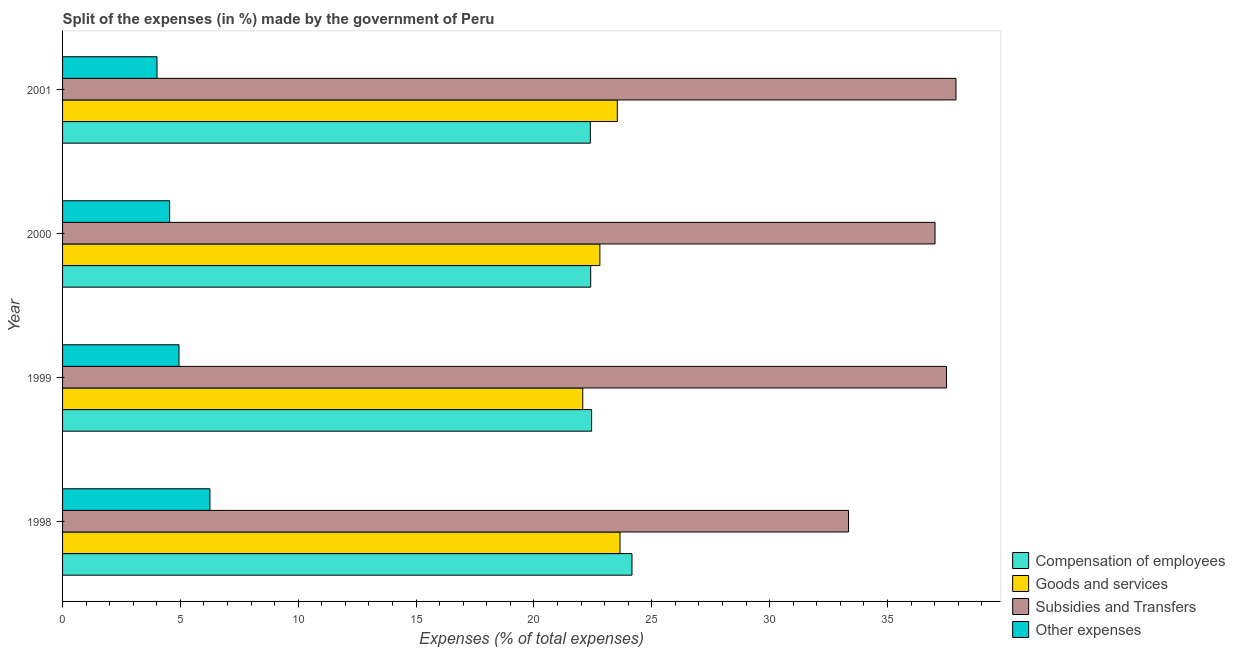How many groups of bars are there?
Your answer should be very brief. 4. Are the number of bars per tick equal to the number of legend labels?
Your response must be concise. Yes. How many bars are there on the 2nd tick from the top?
Keep it short and to the point. 4. What is the label of the 1st group of bars from the top?
Your response must be concise. 2001. What is the percentage of amount spent on goods and services in 2000?
Give a very brief answer. 22.8. Across all years, what is the maximum percentage of amount spent on goods and services?
Ensure brevity in your answer.  23.65. Across all years, what is the minimum percentage of amount spent on compensation of employees?
Offer a very short reply. 22.39. In which year was the percentage of amount spent on goods and services maximum?
Ensure brevity in your answer.  1998. In which year was the percentage of amount spent on other expenses minimum?
Provide a succinct answer. 2001. What is the total percentage of amount spent on goods and services in the graph?
Offer a very short reply. 92.05. What is the difference between the percentage of amount spent on subsidies in 2000 and that in 2001?
Offer a very short reply. -0.89. What is the difference between the percentage of amount spent on goods and services in 2001 and the percentage of amount spent on compensation of employees in 1999?
Keep it short and to the point. 1.09. What is the average percentage of amount spent on compensation of employees per year?
Provide a short and direct response. 22.85. In the year 1998, what is the difference between the percentage of amount spent on goods and services and percentage of amount spent on other expenses?
Make the answer very short. 17.4. What is the ratio of the percentage of amount spent on subsidies in 1999 to that in 2001?
Your response must be concise. 0.99. What is the difference between the highest and the second highest percentage of amount spent on goods and services?
Your answer should be very brief. 0.11. What is the difference between the highest and the lowest percentage of amount spent on compensation of employees?
Ensure brevity in your answer.  1.77. In how many years, is the percentage of amount spent on compensation of employees greater than the average percentage of amount spent on compensation of employees taken over all years?
Provide a short and direct response. 1. Is it the case that in every year, the sum of the percentage of amount spent on compensation of employees and percentage of amount spent on other expenses is greater than the sum of percentage of amount spent on subsidies and percentage of amount spent on goods and services?
Provide a succinct answer. Yes. What does the 3rd bar from the top in 1998 represents?
Your response must be concise. Goods and services. What does the 4th bar from the bottom in 1999 represents?
Provide a succinct answer. Other expenses. Are all the bars in the graph horizontal?
Your response must be concise. Yes. What is the difference between two consecutive major ticks on the X-axis?
Make the answer very short. 5. Does the graph contain grids?
Offer a terse response. No. How many legend labels are there?
Your response must be concise. 4. What is the title of the graph?
Make the answer very short. Split of the expenses (in %) made by the government of Peru. What is the label or title of the X-axis?
Keep it short and to the point. Expenses (% of total expenses). What is the Expenses (% of total expenses) of Compensation of employees in 1998?
Your answer should be compact. 24.16. What is the Expenses (% of total expenses) of Goods and services in 1998?
Offer a terse response. 23.65. What is the Expenses (% of total expenses) in Subsidies and Transfers in 1998?
Offer a very short reply. 33.35. What is the Expenses (% of total expenses) of Other expenses in 1998?
Give a very brief answer. 6.25. What is the Expenses (% of total expenses) of Compensation of employees in 1999?
Your response must be concise. 22.45. What is the Expenses (% of total expenses) in Goods and services in 1999?
Offer a terse response. 22.07. What is the Expenses (% of total expenses) in Subsidies and Transfers in 1999?
Provide a succinct answer. 37.5. What is the Expenses (% of total expenses) of Other expenses in 1999?
Your answer should be compact. 4.94. What is the Expenses (% of total expenses) of Compensation of employees in 2000?
Keep it short and to the point. 22.41. What is the Expenses (% of total expenses) in Goods and services in 2000?
Give a very brief answer. 22.8. What is the Expenses (% of total expenses) of Subsidies and Transfers in 2000?
Your answer should be very brief. 37.01. What is the Expenses (% of total expenses) of Other expenses in 2000?
Ensure brevity in your answer.  4.54. What is the Expenses (% of total expenses) of Compensation of employees in 2001?
Your response must be concise. 22.39. What is the Expenses (% of total expenses) of Goods and services in 2001?
Your response must be concise. 23.54. What is the Expenses (% of total expenses) in Subsidies and Transfers in 2001?
Ensure brevity in your answer.  37.9. What is the Expenses (% of total expenses) in Other expenses in 2001?
Ensure brevity in your answer.  4.01. Across all years, what is the maximum Expenses (% of total expenses) of Compensation of employees?
Your answer should be compact. 24.16. Across all years, what is the maximum Expenses (% of total expenses) of Goods and services?
Provide a succinct answer. 23.65. Across all years, what is the maximum Expenses (% of total expenses) in Subsidies and Transfers?
Ensure brevity in your answer.  37.9. Across all years, what is the maximum Expenses (% of total expenses) of Other expenses?
Offer a very short reply. 6.25. Across all years, what is the minimum Expenses (% of total expenses) of Compensation of employees?
Make the answer very short. 22.39. Across all years, what is the minimum Expenses (% of total expenses) of Goods and services?
Give a very brief answer. 22.07. Across all years, what is the minimum Expenses (% of total expenses) of Subsidies and Transfers?
Your response must be concise. 33.35. Across all years, what is the minimum Expenses (% of total expenses) in Other expenses?
Give a very brief answer. 4.01. What is the total Expenses (% of total expenses) of Compensation of employees in the graph?
Offer a very short reply. 91.4. What is the total Expenses (% of total expenses) of Goods and services in the graph?
Keep it short and to the point. 92.05. What is the total Expenses (% of total expenses) of Subsidies and Transfers in the graph?
Make the answer very short. 145.77. What is the total Expenses (% of total expenses) in Other expenses in the graph?
Provide a succinct answer. 19.74. What is the difference between the Expenses (% of total expenses) in Compensation of employees in 1998 and that in 1999?
Your response must be concise. 1.71. What is the difference between the Expenses (% of total expenses) of Goods and services in 1998 and that in 1999?
Offer a terse response. 1.58. What is the difference between the Expenses (% of total expenses) in Subsidies and Transfers in 1998 and that in 1999?
Your answer should be very brief. -4.16. What is the difference between the Expenses (% of total expenses) of Other expenses in 1998 and that in 1999?
Offer a very short reply. 1.31. What is the difference between the Expenses (% of total expenses) of Compensation of employees in 1998 and that in 2000?
Make the answer very short. 1.75. What is the difference between the Expenses (% of total expenses) in Goods and services in 1998 and that in 2000?
Give a very brief answer. 0.85. What is the difference between the Expenses (% of total expenses) in Subsidies and Transfers in 1998 and that in 2000?
Your response must be concise. -3.67. What is the difference between the Expenses (% of total expenses) in Other expenses in 1998 and that in 2000?
Provide a short and direct response. 1.71. What is the difference between the Expenses (% of total expenses) in Compensation of employees in 1998 and that in 2001?
Provide a succinct answer. 1.77. What is the difference between the Expenses (% of total expenses) in Goods and services in 1998 and that in 2001?
Keep it short and to the point. 0.11. What is the difference between the Expenses (% of total expenses) of Subsidies and Transfers in 1998 and that in 2001?
Provide a short and direct response. -4.56. What is the difference between the Expenses (% of total expenses) of Other expenses in 1998 and that in 2001?
Ensure brevity in your answer.  2.25. What is the difference between the Expenses (% of total expenses) of Compensation of employees in 1999 and that in 2000?
Ensure brevity in your answer.  0.04. What is the difference between the Expenses (% of total expenses) of Goods and services in 1999 and that in 2000?
Keep it short and to the point. -0.73. What is the difference between the Expenses (% of total expenses) in Subsidies and Transfers in 1999 and that in 2000?
Offer a very short reply. 0.49. What is the difference between the Expenses (% of total expenses) in Other expenses in 1999 and that in 2000?
Give a very brief answer. 0.4. What is the difference between the Expenses (% of total expenses) in Compensation of employees in 1999 and that in 2001?
Offer a terse response. 0.05. What is the difference between the Expenses (% of total expenses) of Goods and services in 1999 and that in 2001?
Your answer should be compact. -1.47. What is the difference between the Expenses (% of total expenses) in Subsidies and Transfers in 1999 and that in 2001?
Offer a very short reply. -0.4. What is the difference between the Expenses (% of total expenses) in Other expenses in 1999 and that in 2001?
Keep it short and to the point. 0.93. What is the difference between the Expenses (% of total expenses) in Compensation of employees in 2000 and that in 2001?
Give a very brief answer. 0.02. What is the difference between the Expenses (% of total expenses) of Goods and services in 2000 and that in 2001?
Keep it short and to the point. -0.74. What is the difference between the Expenses (% of total expenses) in Subsidies and Transfers in 2000 and that in 2001?
Your answer should be compact. -0.89. What is the difference between the Expenses (% of total expenses) of Other expenses in 2000 and that in 2001?
Your answer should be very brief. 0.54. What is the difference between the Expenses (% of total expenses) of Compensation of employees in 1998 and the Expenses (% of total expenses) of Goods and services in 1999?
Make the answer very short. 2.09. What is the difference between the Expenses (% of total expenses) in Compensation of employees in 1998 and the Expenses (% of total expenses) in Subsidies and Transfers in 1999?
Your response must be concise. -13.34. What is the difference between the Expenses (% of total expenses) of Compensation of employees in 1998 and the Expenses (% of total expenses) of Other expenses in 1999?
Provide a succinct answer. 19.22. What is the difference between the Expenses (% of total expenses) of Goods and services in 1998 and the Expenses (% of total expenses) of Subsidies and Transfers in 1999?
Offer a very short reply. -13.85. What is the difference between the Expenses (% of total expenses) in Goods and services in 1998 and the Expenses (% of total expenses) in Other expenses in 1999?
Provide a succinct answer. 18.71. What is the difference between the Expenses (% of total expenses) in Subsidies and Transfers in 1998 and the Expenses (% of total expenses) in Other expenses in 1999?
Provide a short and direct response. 28.41. What is the difference between the Expenses (% of total expenses) in Compensation of employees in 1998 and the Expenses (% of total expenses) in Goods and services in 2000?
Provide a short and direct response. 1.36. What is the difference between the Expenses (% of total expenses) in Compensation of employees in 1998 and the Expenses (% of total expenses) in Subsidies and Transfers in 2000?
Ensure brevity in your answer.  -12.86. What is the difference between the Expenses (% of total expenses) of Compensation of employees in 1998 and the Expenses (% of total expenses) of Other expenses in 2000?
Offer a terse response. 19.62. What is the difference between the Expenses (% of total expenses) of Goods and services in 1998 and the Expenses (% of total expenses) of Subsidies and Transfers in 2000?
Ensure brevity in your answer.  -13.36. What is the difference between the Expenses (% of total expenses) in Goods and services in 1998 and the Expenses (% of total expenses) in Other expenses in 2000?
Your response must be concise. 19.11. What is the difference between the Expenses (% of total expenses) in Subsidies and Transfers in 1998 and the Expenses (% of total expenses) in Other expenses in 2000?
Ensure brevity in your answer.  28.8. What is the difference between the Expenses (% of total expenses) in Compensation of employees in 1998 and the Expenses (% of total expenses) in Goods and services in 2001?
Provide a succinct answer. 0.62. What is the difference between the Expenses (% of total expenses) of Compensation of employees in 1998 and the Expenses (% of total expenses) of Subsidies and Transfers in 2001?
Your response must be concise. -13.75. What is the difference between the Expenses (% of total expenses) of Compensation of employees in 1998 and the Expenses (% of total expenses) of Other expenses in 2001?
Offer a terse response. 20.15. What is the difference between the Expenses (% of total expenses) in Goods and services in 1998 and the Expenses (% of total expenses) in Subsidies and Transfers in 2001?
Provide a succinct answer. -14.25. What is the difference between the Expenses (% of total expenses) of Goods and services in 1998 and the Expenses (% of total expenses) of Other expenses in 2001?
Provide a short and direct response. 19.64. What is the difference between the Expenses (% of total expenses) in Subsidies and Transfers in 1998 and the Expenses (% of total expenses) in Other expenses in 2001?
Keep it short and to the point. 29.34. What is the difference between the Expenses (% of total expenses) of Compensation of employees in 1999 and the Expenses (% of total expenses) of Goods and services in 2000?
Provide a succinct answer. -0.35. What is the difference between the Expenses (% of total expenses) of Compensation of employees in 1999 and the Expenses (% of total expenses) of Subsidies and Transfers in 2000?
Make the answer very short. -14.57. What is the difference between the Expenses (% of total expenses) of Compensation of employees in 1999 and the Expenses (% of total expenses) of Other expenses in 2000?
Your answer should be compact. 17.9. What is the difference between the Expenses (% of total expenses) in Goods and services in 1999 and the Expenses (% of total expenses) in Subsidies and Transfers in 2000?
Offer a terse response. -14.94. What is the difference between the Expenses (% of total expenses) of Goods and services in 1999 and the Expenses (% of total expenses) of Other expenses in 2000?
Ensure brevity in your answer.  17.53. What is the difference between the Expenses (% of total expenses) of Subsidies and Transfers in 1999 and the Expenses (% of total expenses) of Other expenses in 2000?
Your answer should be compact. 32.96. What is the difference between the Expenses (% of total expenses) in Compensation of employees in 1999 and the Expenses (% of total expenses) in Goods and services in 2001?
Offer a terse response. -1.09. What is the difference between the Expenses (% of total expenses) in Compensation of employees in 1999 and the Expenses (% of total expenses) in Subsidies and Transfers in 2001?
Provide a succinct answer. -15.46. What is the difference between the Expenses (% of total expenses) in Compensation of employees in 1999 and the Expenses (% of total expenses) in Other expenses in 2001?
Give a very brief answer. 18.44. What is the difference between the Expenses (% of total expenses) of Goods and services in 1999 and the Expenses (% of total expenses) of Subsidies and Transfers in 2001?
Keep it short and to the point. -15.83. What is the difference between the Expenses (% of total expenses) of Goods and services in 1999 and the Expenses (% of total expenses) of Other expenses in 2001?
Give a very brief answer. 18.06. What is the difference between the Expenses (% of total expenses) in Subsidies and Transfers in 1999 and the Expenses (% of total expenses) in Other expenses in 2001?
Your answer should be very brief. 33.49. What is the difference between the Expenses (% of total expenses) of Compensation of employees in 2000 and the Expenses (% of total expenses) of Goods and services in 2001?
Provide a succinct answer. -1.13. What is the difference between the Expenses (% of total expenses) of Compensation of employees in 2000 and the Expenses (% of total expenses) of Subsidies and Transfers in 2001?
Your response must be concise. -15.5. What is the difference between the Expenses (% of total expenses) in Compensation of employees in 2000 and the Expenses (% of total expenses) in Other expenses in 2001?
Provide a succinct answer. 18.4. What is the difference between the Expenses (% of total expenses) in Goods and services in 2000 and the Expenses (% of total expenses) in Subsidies and Transfers in 2001?
Offer a very short reply. -15.11. What is the difference between the Expenses (% of total expenses) in Goods and services in 2000 and the Expenses (% of total expenses) in Other expenses in 2001?
Make the answer very short. 18.79. What is the difference between the Expenses (% of total expenses) of Subsidies and Transfers in 2000 and the Expenses (% of total expenses) of Other expenses in 2001?
Provide a succinct answer. 33.01. What is the average Expenses (% of total expenses) of Compensation of employees per year?
Your response must be concise. 22.85. What is the average Expenses (% of total expenses) of Goods and services per year?
Make the answer very short. 23.01. What is the average Expenses (% of total expenses) in Subsidies and Transfers per year?
Your answer should be very brief. 36.44. What is the average Expenses (% of total expenses) in Other expenses per year?
Offer a very short reply. 4.94. In the year 1998, what is the difference between the Expenses (% of total expenses) in Compensation of employees and Expenses (% of total expenses) in Goods and services?
Offer a very short reply. 0.51. In the year 1998, what is the difference between the Expenses (% of total expenses) of Compensation of employees and Expenses (% of total expenses) of Subsidies and Transfers?
Ensure brevity in your answer.  -9.19. In the year 1998, what is the difference between the Expenses (% of total expenses) in Compensation of employees and Expenses (% of total expenses) in Other expenses?
Keep it short and to the point. 17.91. In the year 1998, what is the difference between the Expenses (% of total expenses) in Goods and services and Expenses (% of total expenses) in Subsidies and Transfers?
Offer a terse response. -9.7. In the year 1998, what is the difference between the Expenses (% of total expenses) in Goods and services and Expenses (% of total expenses) in Other expenses?
Provide a succinct answer. 17.4. In the year 1998, what is the difference between the Expenses (% of total expenses) in Subsidies and Transfers and Expenses (% of total expenses) in Other expenses?
Your answer should be compact. 27.09. In the year 1999, what is the difference between the Expenses (% of total expenses) in Compensation of employees and Expenses (% of total expenses) in Subsidies and Transfers?
Keep it short and to the point. -15.06. In the year 1999, what is the difference between the Expenses (% of total expenses) of Compensation of employees and Expenses (% of total expenses) of Other expenses?
Your answer should be compact. 17.51. In the year 1999, what is the difference between the Expenses (% of total expenses) of Goods and services and Expenses (% of total expenses) of Subsidies and Transfers?
Make the answer very short. -15.43. In the year 1999, what is the difference between the Expenses (% of total expenses) in Goods and services and Expenses (% of total expenses) in Other expenses?
Provide a short and direct response. 17.13. In the year 1999, what is the difference between the Expenses (% of total expenses) in Subsidies and Transfers and Expenses (% of total expenses) in Other expenses?
Give a very brief answer. 32.56. In the year 2000, what is the difference between the Expenses (% of total expenses) of Compensation of employees and Expenses (% of total expenses) of Goods and services?
Provide a short and direct response. -0.39. In the year 2000, what is the difference between the Expenses (% of total expenses) of Compensation of employees and Expenses (% of total expenses) of Subsidies and Transfers?
Keep it short and to the point. -14.61. In the year 2000, what is the difference between the Expenses (% of total expenses) of Compensation of employees and Expenses (% of total expenses) of Other expenses?
Keep it short and to the point. 17.86. In the year 2000, what is the difference between the Expenses (% of total expenses) of Goods and services and Expenses (% of total expenses) of Subsidies and Transfers?
Your response must be concise. -14.22. In the year 2000, what is the difference between the Expenses (% of total expenses) in Goods and services and Expenses (% of total expenses) in Other expenses?
Your answer should be compact. 18.25. In the year 2000, what is the difference between the Expenses (% of total expenses) in Subsidies and Transfers and Expenses (% of total expenses) in Other expenses?
Your response must be concise. 32.47. In the year 2001, what is the difference between the Expenses (% of total expenses) of Compensation of employees and Expenses (% of total expenses) of Goods and services?
Provide a succinct answer. -1.15. In the year 2001, what is the difference between the Expenses (% of total expenses) in Compensation of employees and Expenses (% of total expenses) in Subsidies and Transfers?
Ensure brevity in your answer.  -15.51. In the year 2001, what is the difference between the Expenses (% of total expenses) of Compensation of employees and Expenses (% of total expenses) of Other expenses?
Provide a succinct answer. 18.38. In the year 2001, what is the difference between the Expenses (% of total expenses) of Goods and services and Expenses (% of total expenses) of Subsidies and Transfers?
Your answer should be compact. -14.37. In the year 2001, what is the difference between the Expenses (% of total expenses) in Goods and services and Expenses (% of total expenses) in Other expenses?
Offer a terse response. 19.53. In the year 2001, what is the difference between the Expenses (% of total expenses) of Subsidies and Transfers and Expenses (% of total expenses) of Other expenses?
Ensure brevity in your answer.  33.9. What is the ratio of the Expenses (% of total expenses) in Compensation of employees in 1998 to that in 1999?
Offer a terse response. 1.08. What is the ratio of the Expenses (% of total expenses) in Goods and services in 1998 to that in 1999?
Keep it short and to the point. 1.07. What is the ratio of the Expenses (% of total expenses) in Subsidies and Transfers in 1998 to that in 1999?
Your answer should be very brief. 0.89. What is the ratio of the Expenses (% of total expenses) of Other expenses in 1998 to that in 1999?
Offer a terse response. 1.27. What is the ratio of the Expenses (% of total expenses) in Compensation of employees in 1998 to that in 2000?
Offer a very short reply. 1.08. What is the ratio of the Expenses (% of total expenses) in Goods and services in 1998 to that in 2000?
Keep it short and to the point. 1.04. What is the ratio of the Expenses (% of total expenses) of Subsidies and Transfers in 1998 to that in 2000?
Keep it short and to the point. 0.9. What is the ratio of the Expenses (% of total expenses) in Other expenses in 1998 to that in 2000?
Your answer should be compact. 1.38. What is the ratio of the Expenses (% of total expenses) of Compensation of employees in 1998 to that in 2001?
Provide a short and direct response. 1.08. What is the ratio of the Expenses (% of total expenses) in Goods and services in 1998 to that in 2001?
Offer a terse response. 1. What is the ratio of the Expenses (% of total expenses) in Subsidies and Transfers in 1998 to that in 2001?
Your response must be concise. 0.88. What is the ratio of the Expenses (% of total expenses) of Other expenses in 1998 to that in 2001?
Your response must be concise. 1.56. What is the ratio of the Expenses (% of total expenses) in Goods and services in 1999 to that in 2000?
Your response must be concise. 0.97. What is the ratio of the Expenses (% of total expenses) of Subsidies and Transfers in 1999 to that in 2000?
Make the answer very short. 1.01. What is the ratio of the Expenses (% of total expenses) of Other expenses in 1999 to that in 2000?
Make the answer very short. 1.09. What is the ratio of the Expenses (% of total expenses) in Compensation of employees in 1999 to that in 2001?
Your answer should be compact. 1. What is the ratio of the Expenses (% of total expenses) in Goods and services in 1999 to that in 2001?
Provide a succinct answer. 0.94. What is the ratio of the Expenses (% of total expenses) in Other expenses in 1999 to that in 2001?
Your answer should be compact. 1.23. What is the ratio of the Expenses (% of total expenses) of Compensation of employees in 2000 to that in 2001?
Offer a very short reply. 1. What is the ratio of the Expenses (% of total expenses) of Goods and services in 2000 to that in 2001?
Your answer should be very brief. 0.97. What is the ratio of the Expenses (% of total expenses) in Subsidies and Transfers in 2000 to that in 2001?
Provide a short and direct response. 0.98. What is the ratio of the Expenses (% of total expenses) of Other expenses in 2000 to that in 2001?
Provide a succinct answer. 1.13. What is the difference between the highest and the second highest Expenses (% of total expenses) in Compensation of employees?
Provide a short and direct response. 1.71. What is the difference between the highest and the second highest Expenses (% of total expenses) of Goods and services?
Your answer should be very brief. 0.11. What is the difference between the highest and the second highest Expenses (% of total expenses) of Subsidies and Transfers?
Ensure brevity in your answer.  0.4. What is the difference between the highest and the second highest Expenses (% of total expenses) in Other expenses?
Make the answer very short. 1.31. What is the difference between the highest and the lowest Expenses (% of total expenses) of Compensation of employees?
Offer a terse response. 1.77. What is the difference between the highest and the lowest Expenses (% of total expenses) of Goods and services?
Ensure brevity in your answer.  1.58. What is the difference between the highest and the lowest Expenses (% of total expenses) in Subsidies and Transfers?
Offer a very short reply. 4.56. What is the difference between the highest and the lowest Expenses (% of total expenses) of Other expenses?
Offer a terse response. 2.25. 